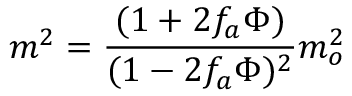<formula> <loc_0><loc_0><loc_500><loc_500>m ^ { 2 } = \frac { ( 1 + 2 f _ { a } \Phi ) } { ( 1 - 2 f _ { a } \Phi ) ^ { 2 } } m _ { o } ^ { 2 }</formula> 